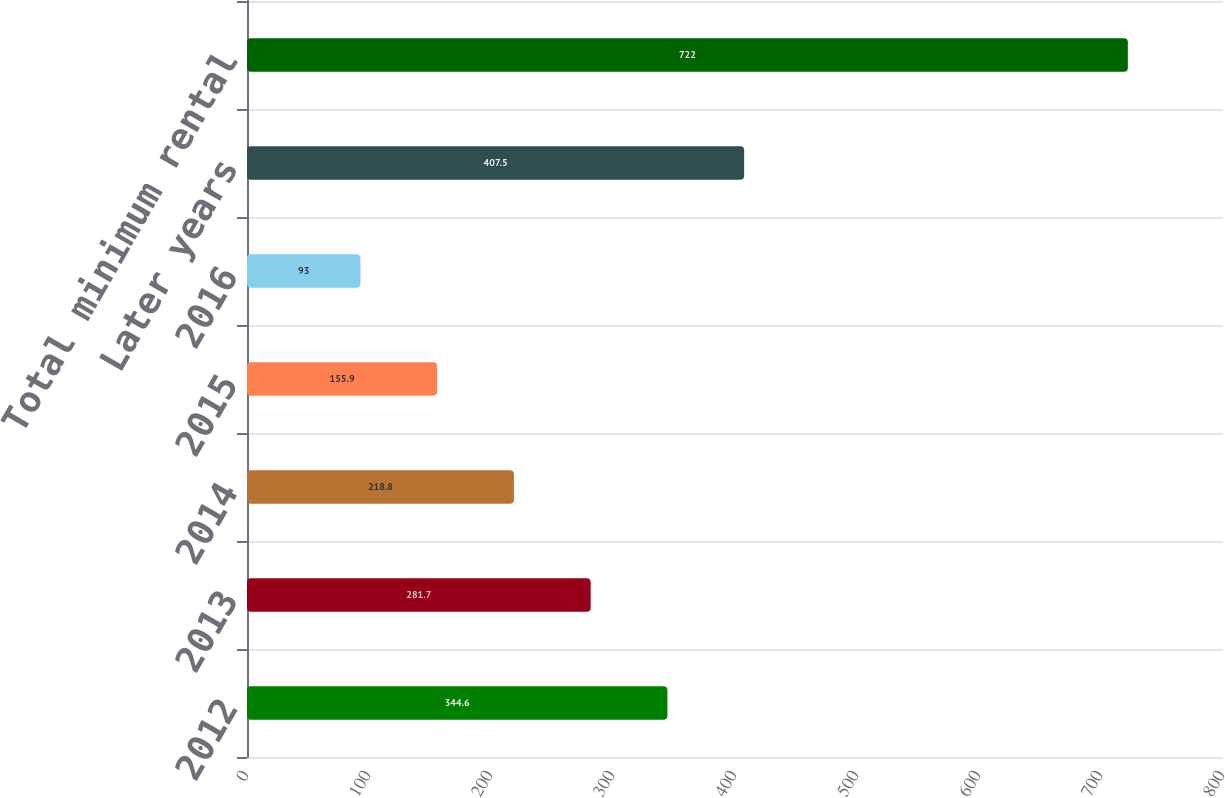Convert chart to OTSL. <chart><loc_0><loc_0><loc_500><loc_500><bar_chart><fcel>2012<fcel>2013<fcel>2014<fcel>2015<fcel>2016<fcel>Later years<fcel>Total minimum rental<nl><fcel>344.6<fcel>281.7<fcel>218.8<fcel>155.9<fcel>93<fcel>407.5<fcel>722<nl></chart> 